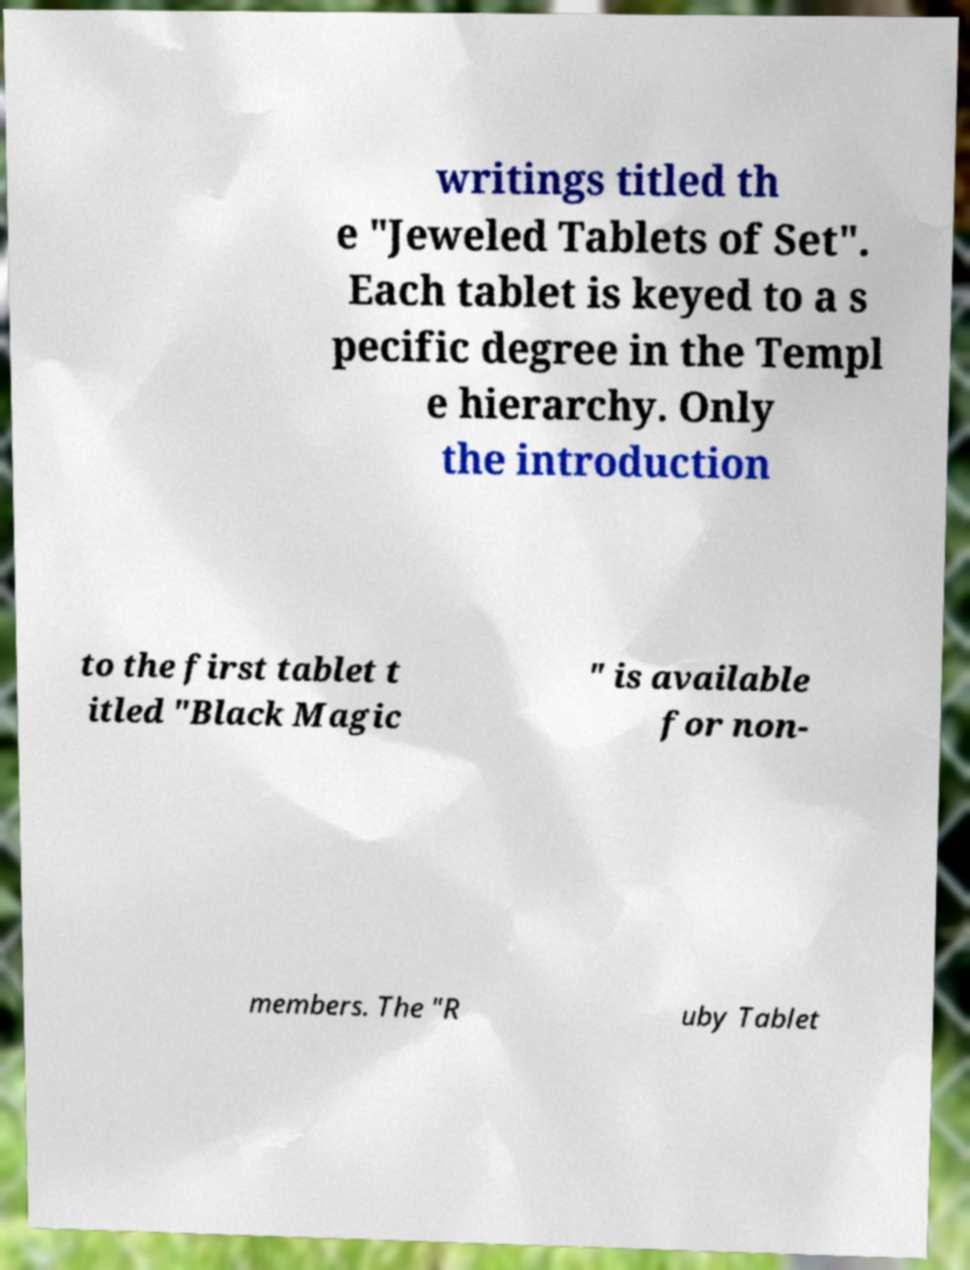Please read and relay the text visible in this image. What does it say? writings titled th e "Jeweled Tablets of Set". Each tablet is keyed to a s pecific degree in the Templ e hierarchy. Only the introduction to the first tablet t itled "Black Magic " is available for non- members. The "R uby Tablet 